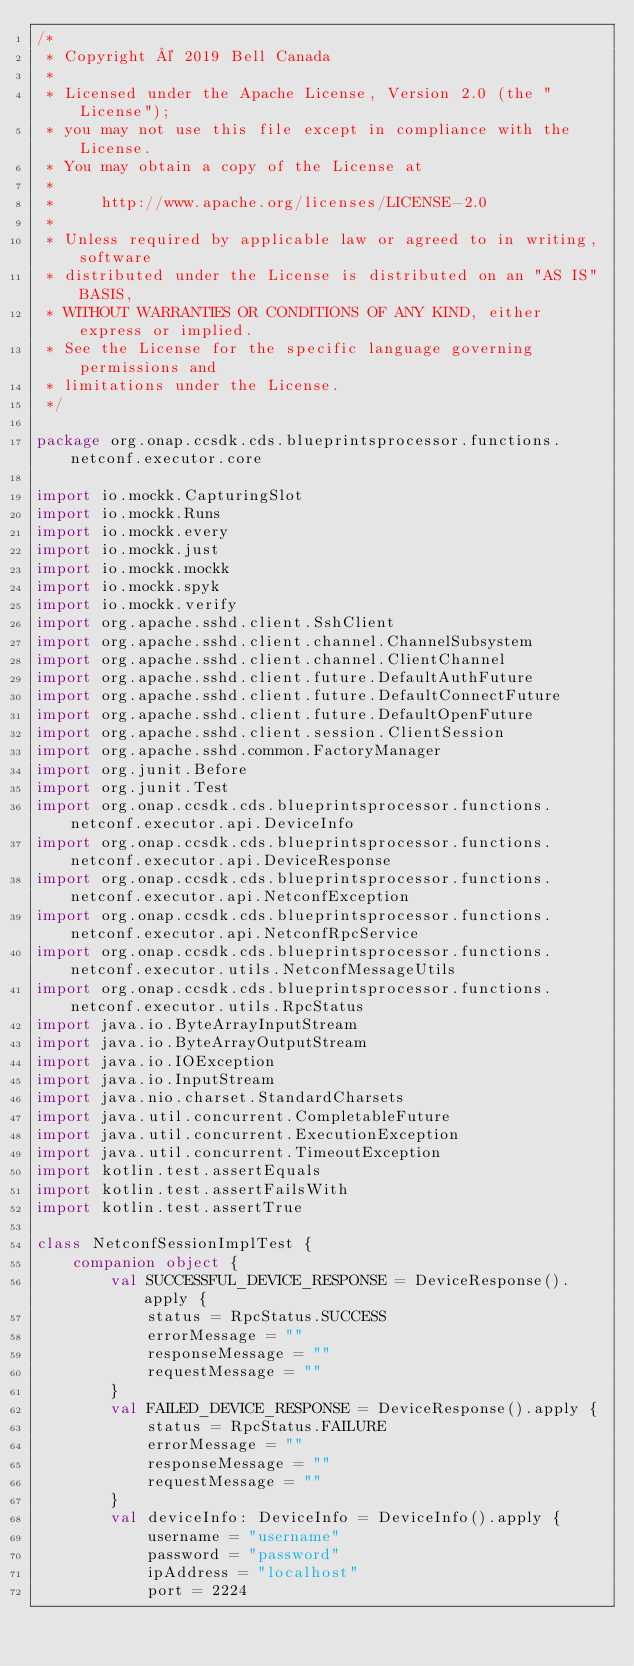<code> <loc_0><loc_0><loc_500><loc_500><_Kotlin_>/*
 * Copyright © 2019 Bell Canada
 *
 * Licensed under the Apache License, Version 2.0 (the "License");
 * you may not use this file except in compliance with the License.
 * You may obtain a copy of the License at
 *
 *     http://www.apache.org/licenses/LICENSE-2.0
 *
 * Unless required by applicable law or agreed to in writing, software
 * distributed under the License is distributed on an "AS IS" BASIS,
 * WITHOUT WARRANTIES OR CONDITIONS OF ANY KIND, either express or implied.
 * See the License for the specific language governing permissions and
 * limitations under the License.
 */

package org.onap.ccsdk.cds.blueprintsprocessor.functions.netconf.executor.core

import io.mockk.CapturingSlot
import io.mockk.Runs
import io.mockk.every
import io.mockk.just
import io.mockk.mockk
import io.mockk.spyk
import io.mockk.verify
import org.apache.sshd.client.SshClient
import org.apache.sshd.client.channel.ChannelSubsystem
import org.apache.sshd.client.channel.ClientChannel
import org.apache.sshd.client.future.DefaultAuthFuture
import org.apache.sshd.client.future.DefaultConnectFuture
import org.apache.sshd.client.future.DefaultOpenFuture
import org.apache.sshd.client.session.ClientSession
import org.apache.sshd.common.FactoryManager
import org.junit.Before
import org.junit.Test
import org.onap.ccsdk.cds.blueprintsprocessor.functions.netconf.executor.api.DeviceInfo
import org.onap.ccsdk.cds.blueprintsprocessor.functions.netconf.executor.api.DeviceResponse
import org.onap.ccsdk.cds.blueprintsprocessor.functions.netconf.executor.api.NetconfException
import org.onap.ccsdk.cds.blueprintsprocessor.functions.netconf.executor.api.NetconfRpcService
import org.onap.ccsdk.cds.blueprintsprocessor.functions.netconf.executor.utils.NetconfMessageUtils
import org.onap.ccsdk.cds.blueprintsprocessor.functions.netconf.executor.utils.RpcStatus
import java.io.ByteArrayInputStream
import java.io.ByteArrayOutputStream
import java.io.IOException
import java.io.InputStream
import java.nio.charset.StandardCharsets
import java.util.concurrent.CompletableFuture
import java.util.concurrent.ExecutionException
import java.util.concurrent.TimeoutException
import kotlin.test.assertEquals
import kotlin.test.assertFailsWith
import kotlin.test.assertTrue

class NetconfSessionImplTest {
    companion object {
        val SUCCESSFUL_DEVICE_RESPONSE = DeviceResponse().apply {
            status = RpcStatus.SUCCESS
            errorMessage = ""
            responseMessage = ""
            requestMessage = ""
        }
        val FAILED_DEVICE_RESPONSE = DeviceResponse().apply {
            status = RpcStatus.FAILURE
            errorMessage = ""
            responseMessage = ""
            requestMessage = ""
        }
        val deviceInfo: DeviceInfo = DeviceInfo().apply {
            username = "username"
            password = "password"
            ipAddress = "localhost"
            port = 2224</code> 